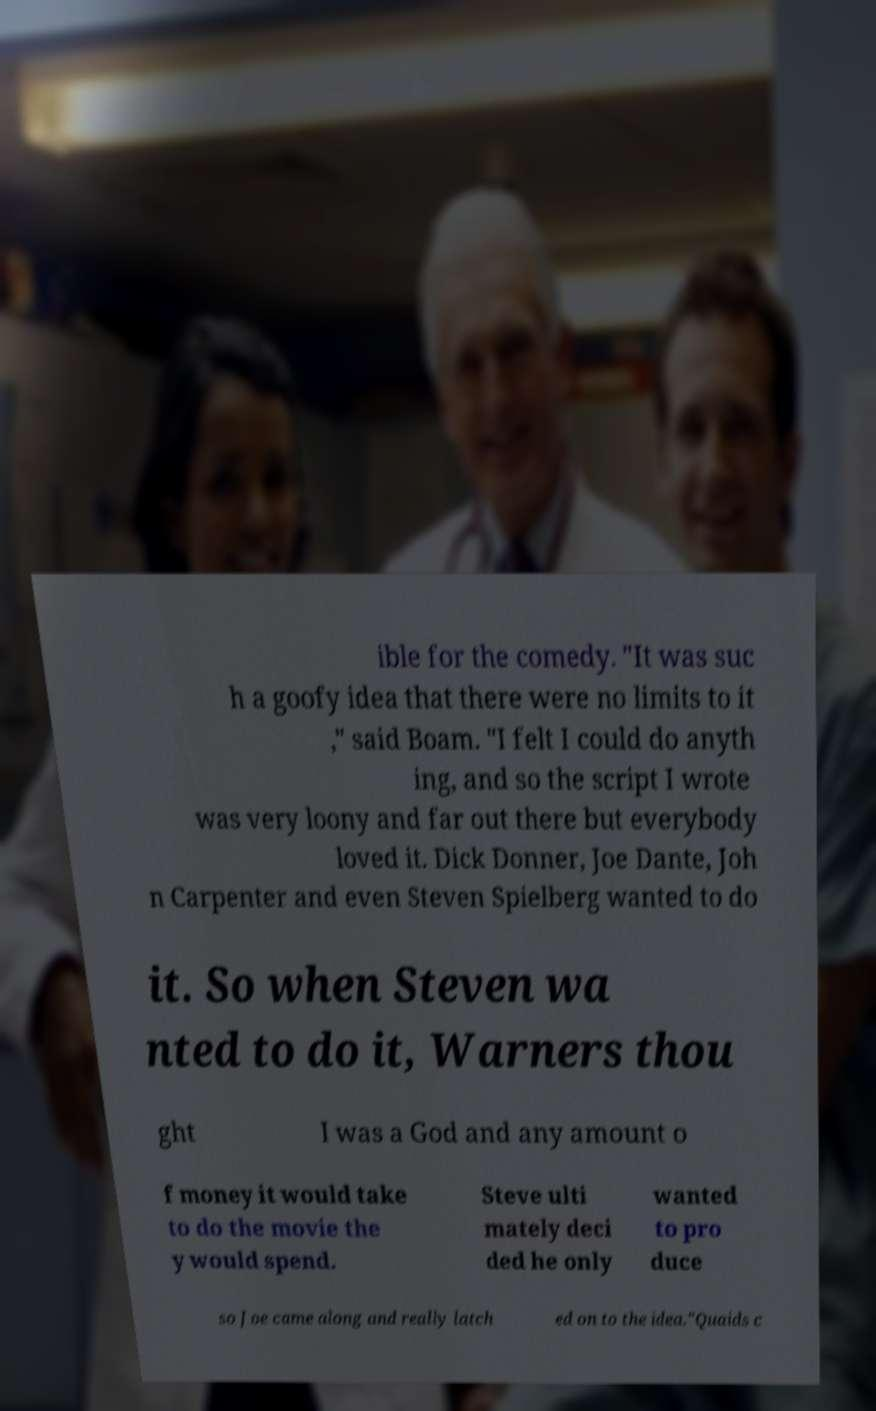Can you read and provide the text displayed in the image?This photo seems to have some interesting text. Can you extract and type it out for me? ible for the comedy. "It was suc h a goofy idea that there were no limits to it ," said Boam. "I felt I could do anyth ing, and so the script I wrote was very loony and far out there but everybody loved it. Dick Donner, Joe Dante, Joh n Carpenter and even Steven Spielberg wanted to do it. So when Steven wa nted to do it, Warners thou ght I was a God and any amount o f money it would take to do the movie the y would spend. Steve ulti mately deci ded he only wanted to pro duce so Joe came along and really latch ed on to the idea."Quaids c 